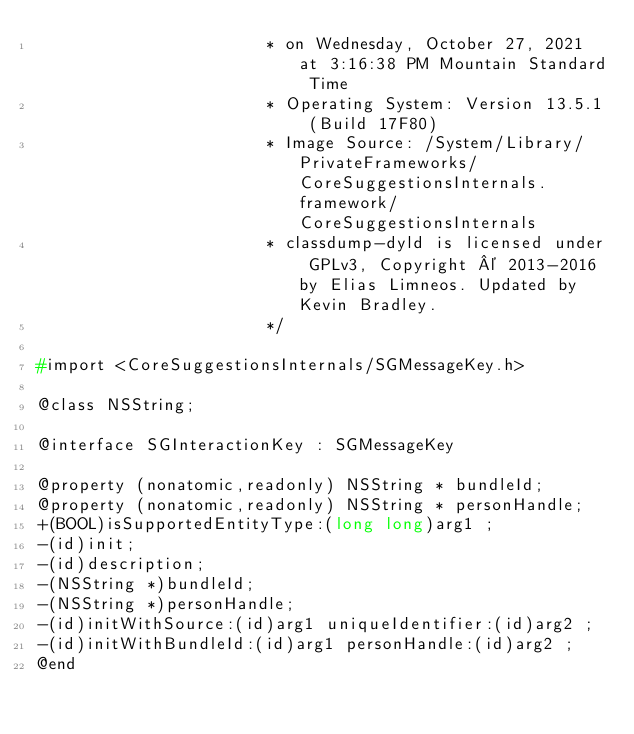<code> <loc_0><loc_0><loc_500><loc_500><_C_>                       * on Wednesday, October 27, 2021 at 3:16:38 PM Mountain Standard Time
                       * Operating System: Version 13.5.1 (Build 17F80)
                       * Image Source: /System/Library/PrivateFrameworks/CoreSuggestionsInternals.framework/CoreSuggestionsInternals
                       * classdump-dyld is licensed under GPLv3, Copyright © 2013-2016 by Elias Limneos. Updated by Kevin Bradley.
                       */

#import <CoreSuggestionsInternals/SGMessageKey.h>

@class NSString;

@interface SGInteractionKey : SGMessageKey

@property (nonatomic,readonly) NSString * bundleId; 
@property (nonatomic,readonly) NSString * personHandle; 
+(BOOL)isSupportedEntityType:(long long)arg1 ;
-(id)init;
-(id)description;
-(NSString *)bundleId;
-(NSString *)personHandle;
-(id)initWithSource:(id)arg1 uniqueIdentifier:(id)arg2 ;
-(id)initWithBundleId:(id)arg1 personHandle:(id)arg2 ;
@end

</code> 